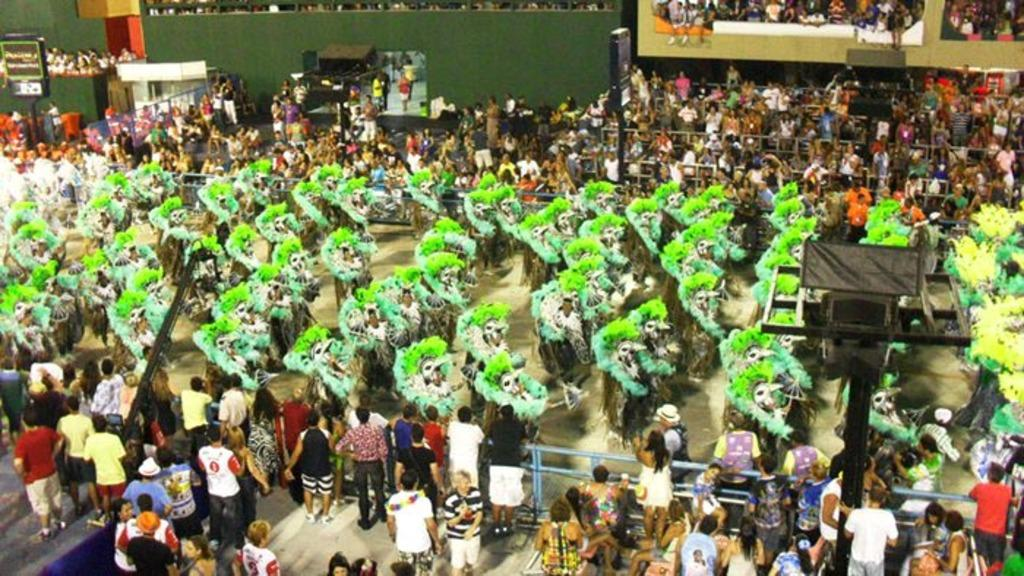What are the people in the image wearing? The people in the image are wearing costumes. What can be seen in the background of the image? There is a fence, poles, boards, and a wall in the image. How many people are present in the image? There are people in the image. What else can be seen in the image besides the people and the background elements? There are objects in the image. How many balloons are being used to wash the chairs in the image? There are no balloons or chairs present in the image. 